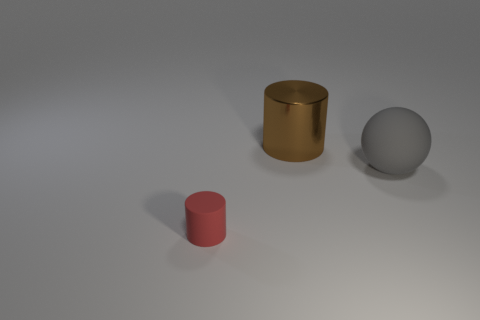Are there any other objects that have the same shape as the small red rubber thing?
Your answer should be very brief. Yes. There is a thing that is the same size as the shiny cylinder; what material is it?
Keep it short and to the point. Rubber. Are there any tiny red objects in front of the red object?
Keep it short and to the point. No. There is a tiny rubber object; is it the same shape as the large object that is to the left of the big gray ball?
Offer a terse response. Yes. What number of things are either cylinders that are on the left side of the large shiny cylinder or rubber objects?
Give a very brief answer. 2. Are there any other things that are the same material as the big cylinder?
Keep it short and to the point. No. What number of cylinders are both behind the big sphere and left of the large shiny object?
Your answer should be compact. 0. What number of objects are brown things that are behind the small red rubber thing or objects that are to the right of the shiny thing?
Keep it short and to the point. 2. How many other objects are the same shape as the big matte object?
Keep it short and to the point. 0. How many other things are there of the same size as the brown shiny thing?
Your answer should be compact. 1. 